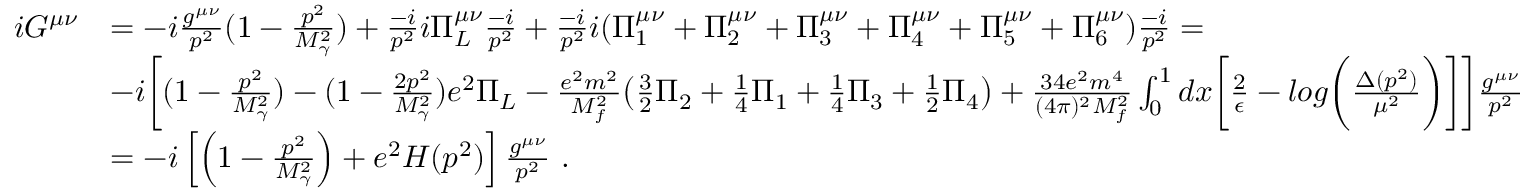<formula> <loc_0><loc_0><loc_500><loc_500>\begin{array} { r l } { i G ^ { \mu \nu } } & { = - i \frac { g ^ { \mu \nu } } { p ^ { 2 } } ( 1 - \frac { p ^ { 2 } } { M _ { \gamma } ^ { 2 } } ) + \frac { - i } { p ^ { 2 } } i \Pi _ { L } ^ { \mu \nu } \frac { - i } { p ^ { 2 } } + \frac { - i } { p ^ { 2 } } i ( \Pi _ { 1 } ^ { \mu \nu } + \Pi _ { 2 } ^ { \mu \nu } + \Pi _ { 3 } ^ { \mu \nu } + \Pi _ { 4 } ^ { \mu \nu } + \Pi _ { 5 } ^ { \mu \nu } + \Pi _ { 6 } ^ { \mu \nu } ) \frac { - i } { p ^ { 2 } } = } \\ & { - i \left [ ( 1 - \frac { p ^ { 2 } } { M _ { \gamma } ^ { 2 } } ) - ( 1 - \frac { 2 p ^ { 2 } } { M _ { \gamma } ^ { 2 } } ) e ^ { 2 } \Pi _ { L } - \frac { e ^ { 2 } m ^ { 2 } } { M _ { f } ^ { 2 } } \left ( \frac { 3 } { 2 } \Pi _ { 2 } + \frac { 1 } { 4 } \Pi _ { 1 } + \frac { 1 } { 4 } \Pi _ { 3 } + \frac { 1 } { 2 } \Pi _ { 4 } \right ) + \frac { 3 4 e ^ { 2 } m ^ { 4 } } { ( 4 \pi ) ^ { 2 } M _ { f } ^ { 2 } } \int _ { 0 } ^ { 1 } d x \left [ \frac { 2 } { \epsilon } - \log \left ( \frac { \Delta ( p ^ { 2 } ) } { \mu ^ { 2 } } \right ) \right ] \right ] \frac { g ^ { \mu \nu } } { p ^ { 2 } } } \\ & { = - i \left [ \left ( 1 - \frac { p ^ { 2 } } { M _ { \gamma } ^ { 2 } } \right ) + e ^ { 2 } H ( p ^ { 2 } ) \right ] \frac { g ^ { \mu \nu } } { p ^ { 2 } } \ . } \end{array}</formula> 